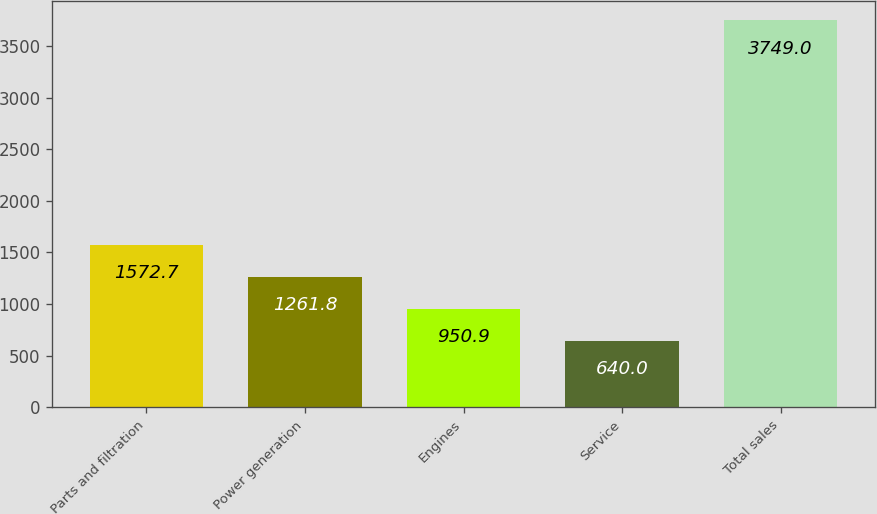Convert chart. <chart><loc_0><loc_0><loc_500><loc_500><bar_chart><fcel>Parts and filtration<fcel>Power generation<fcel>Engines<fcel>Service<fcel>Total sales<nl><fcel>1572.7<fcel>1261.8<fcel>950.9<fcel>640<fcel>3749<nl></chart> 